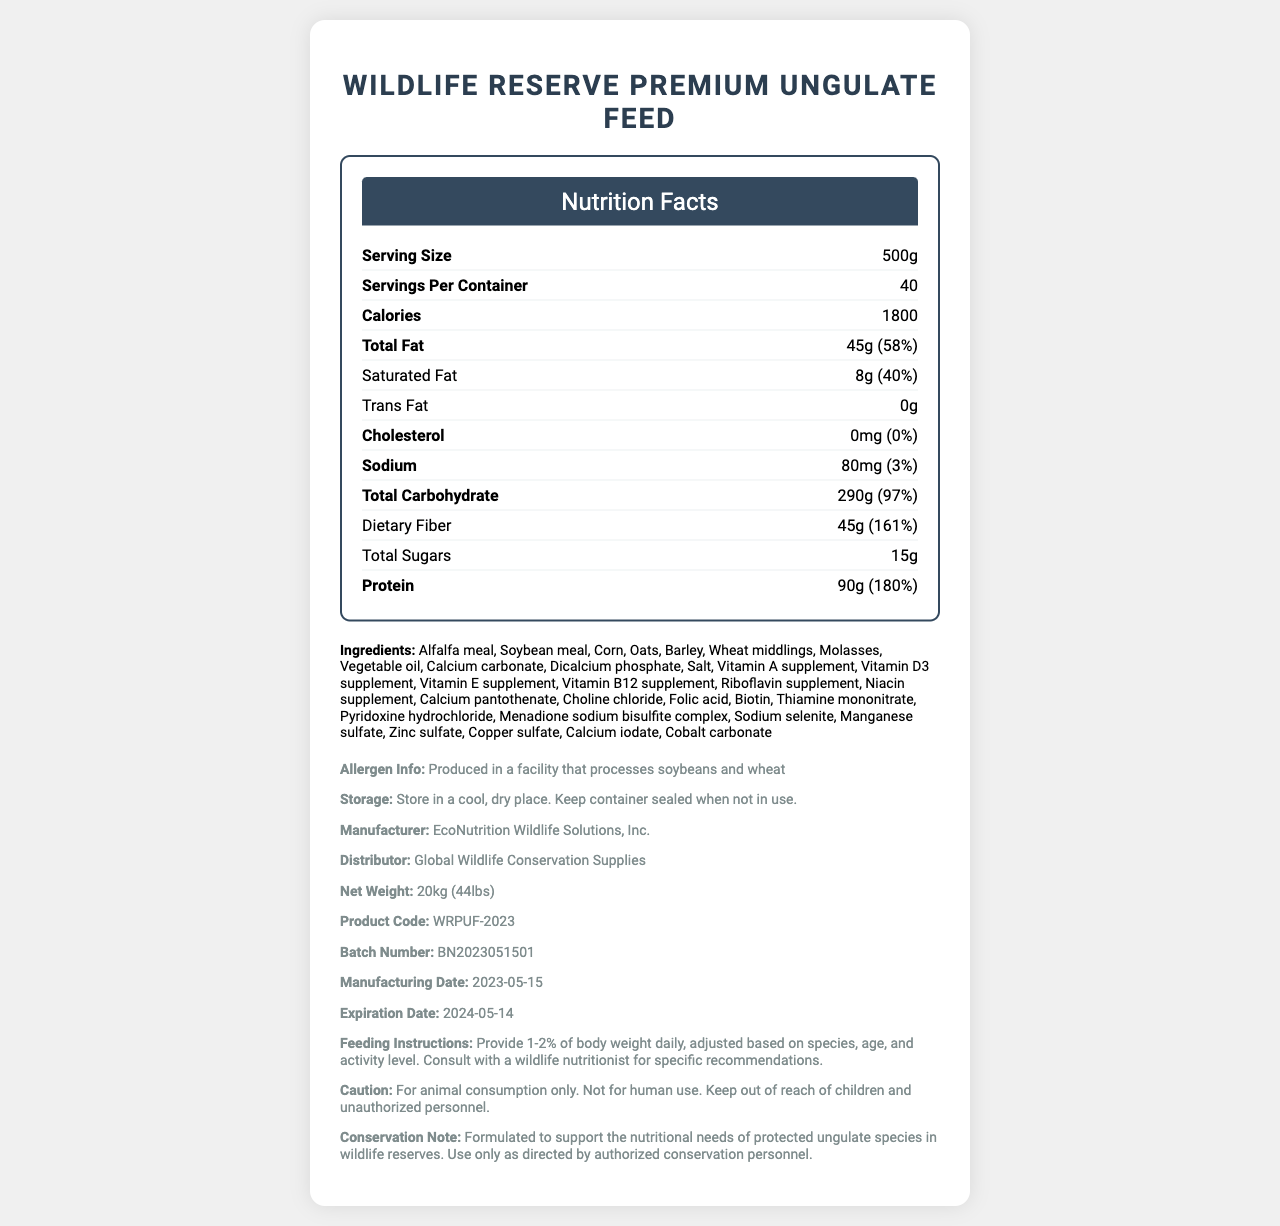what is the serving size for WildLife Reserve Premium Ungulate Feed? The serving size is specified on the document as 500g.
Answer: 500g How many calories are there per serving? The document states that each serving contains 1800 calories.
Answer: 1800 calories How much total fat is in one serving, and what percentage of the daily value does it represent? The document lists the total fat as 45g, which represents 58% of the daily value.
Answer: 45g, 58% How much protein does one serving of the feed contain? The amount of protein per serving is stated to be 90g.
Answer: 90g Which component is not present in the WildLife Reserve Premium Ungulate Feed? The nutrition facts indicate that the trans fat content is 0g.
Answer: Trans fat What is the manufacturing date of the product? The manufacturing date is noted as 2023-05-15 in the document.
Answer: 2023-05-15 What are the ingredients of the product? All these ingredients are listed in the document.
Answer: Alfalfa meal, Soybean meal, Corn, Oats, Barley, Wheat middlings, Molasses, Vegetable oil, Calcium carbonate, Dicalcium phosphate, Salt, Vitamin A supplement, Vitamin D3 supplement, Vitamin E supplement, Vitamin B12 supplement, Riboflavin supplement, Niacin supplement, Calcium pantothenate, Choline chloride, Folic acid, Biotin, Thiamine mononitrate, Pyridoxine hydrochloride, Menadione sodium bisulfite complex, Sodium selenite, Manganese sulfate, Zinc sulfate, Copper sulfate, Calcium iodate, Cobalt carbonate What is the recommended daily feeding amount? The feeding instructions specify to provide 1-2% of body weight daily, adjusted based on species, age, and activity level.
Answer: Provide 1-2% of body weight daily, adjusted based on species, age, and activity level. Which vitamin is present in the highest amount per serving? A. Vitamin A B. Vitamin C C. Vitamin B12 Vitamin A has 2500IU, whereas Vitamin C has 60mg, and Vitamin B12 has 6mcg per serving.
Answer: A. Vitamin A How much sodium does one serving contain? A. 80mg B. 50mg C. 100mg D. 30mg The document specifies that one serving contains 80mg of sodium.
Answer: A. 80mg Is the product suitable for human consumption? The caution section explicitly states "For animal consumption only. Not for human use."
Answer: No What can be inferred about the intended users of this product based on the document? The conservation note mentions the product is formulated to support the nutritional needs of protected ungulate species in wildlife reserves.
Answer: It is formulated for protected ungulate species in wildlife reserves How should the WildLife Reserve Premium Ungulate Feed be stored? The storage instructions specify to store in a cool, dry place and to keep the container sealed when not in use.
Answer: Store in a cool, dry place. Keep container sealed when not in use. What is the main purpose of the WildLife Reserve Premium Ungulate Feed? The conservation note indicates that this feed is designed to support the nutritional needs of protected ungulate species in wildlife reserves.
Answer: To support the nutritional needs of protected ungulate species in wildlife reserves What is the vitamin E content per serving? The document lists the vitamin E content as 100IU per serving.
Answer: 100IU Can the exact origin of the ingredients be determined from the document? The document does not specify the origin of the ingredients used in the feed.
Answer: Cannot be determined 